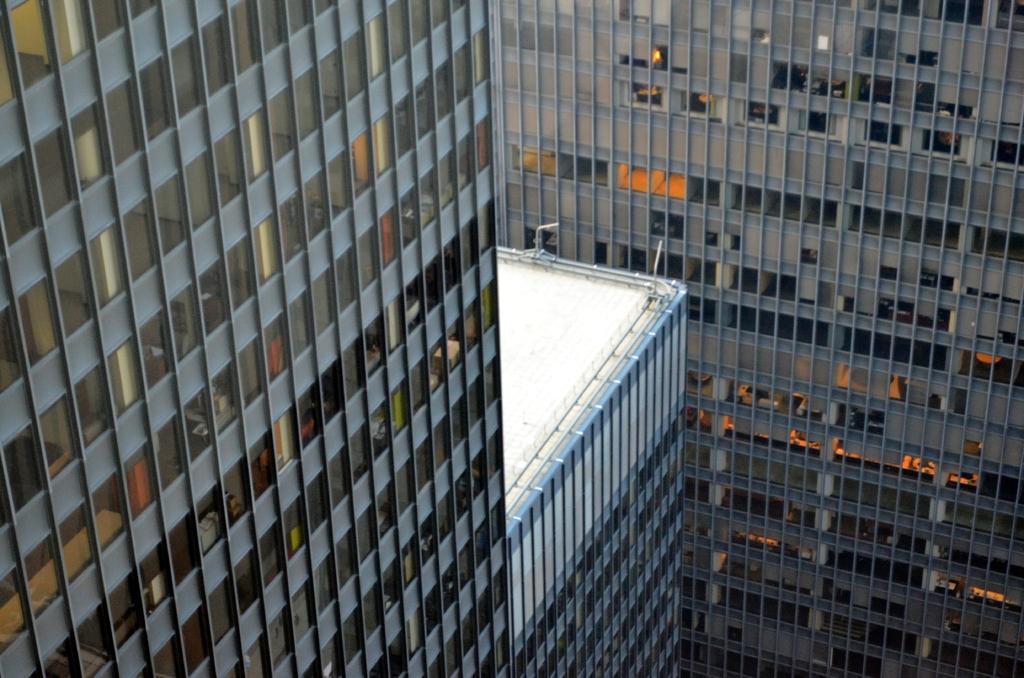Please provide a concise description of this image. In this image we can see there are buildings with windows. 